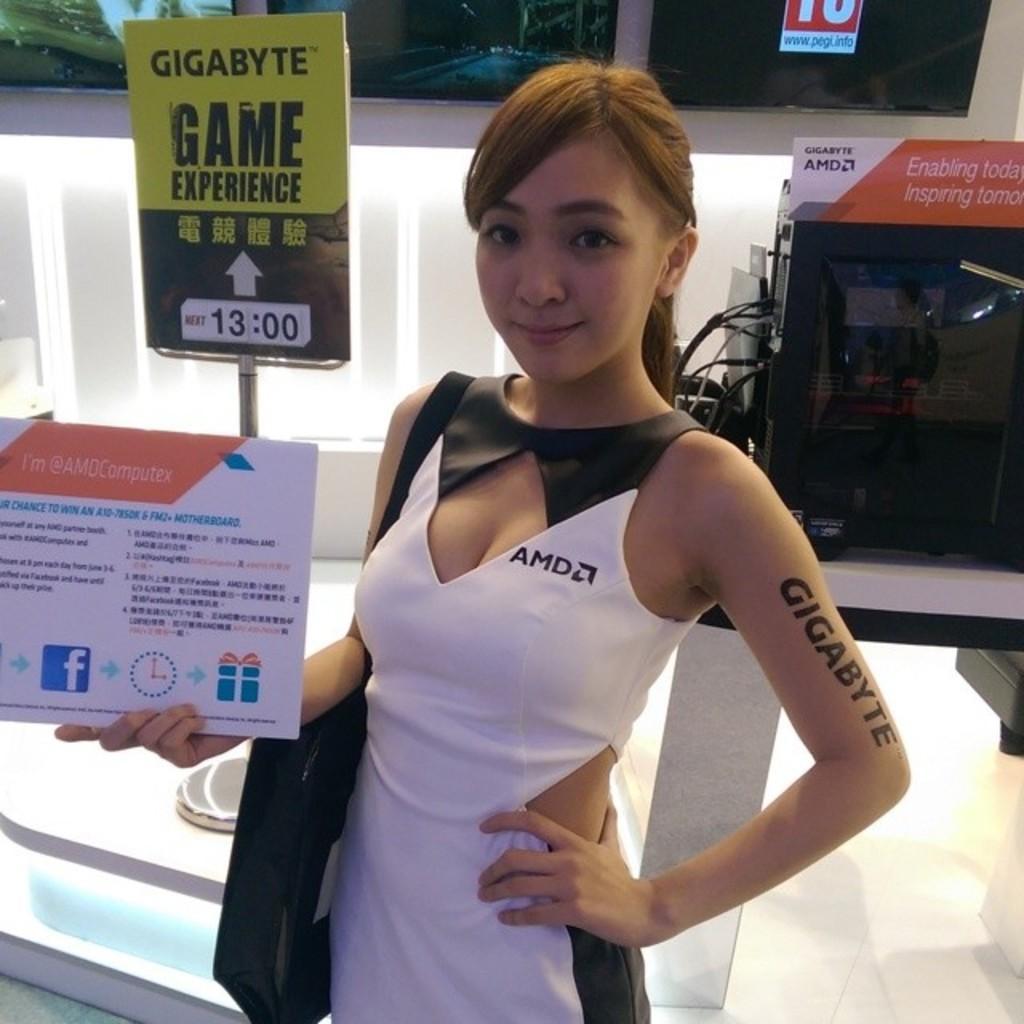How would you summarize this image in a sentence or two? In the middle I can see a woman is holding a board in hand is wearing a bag. In the background I can see a board, machine, wall and a window. This image is taken may be in a hall. 